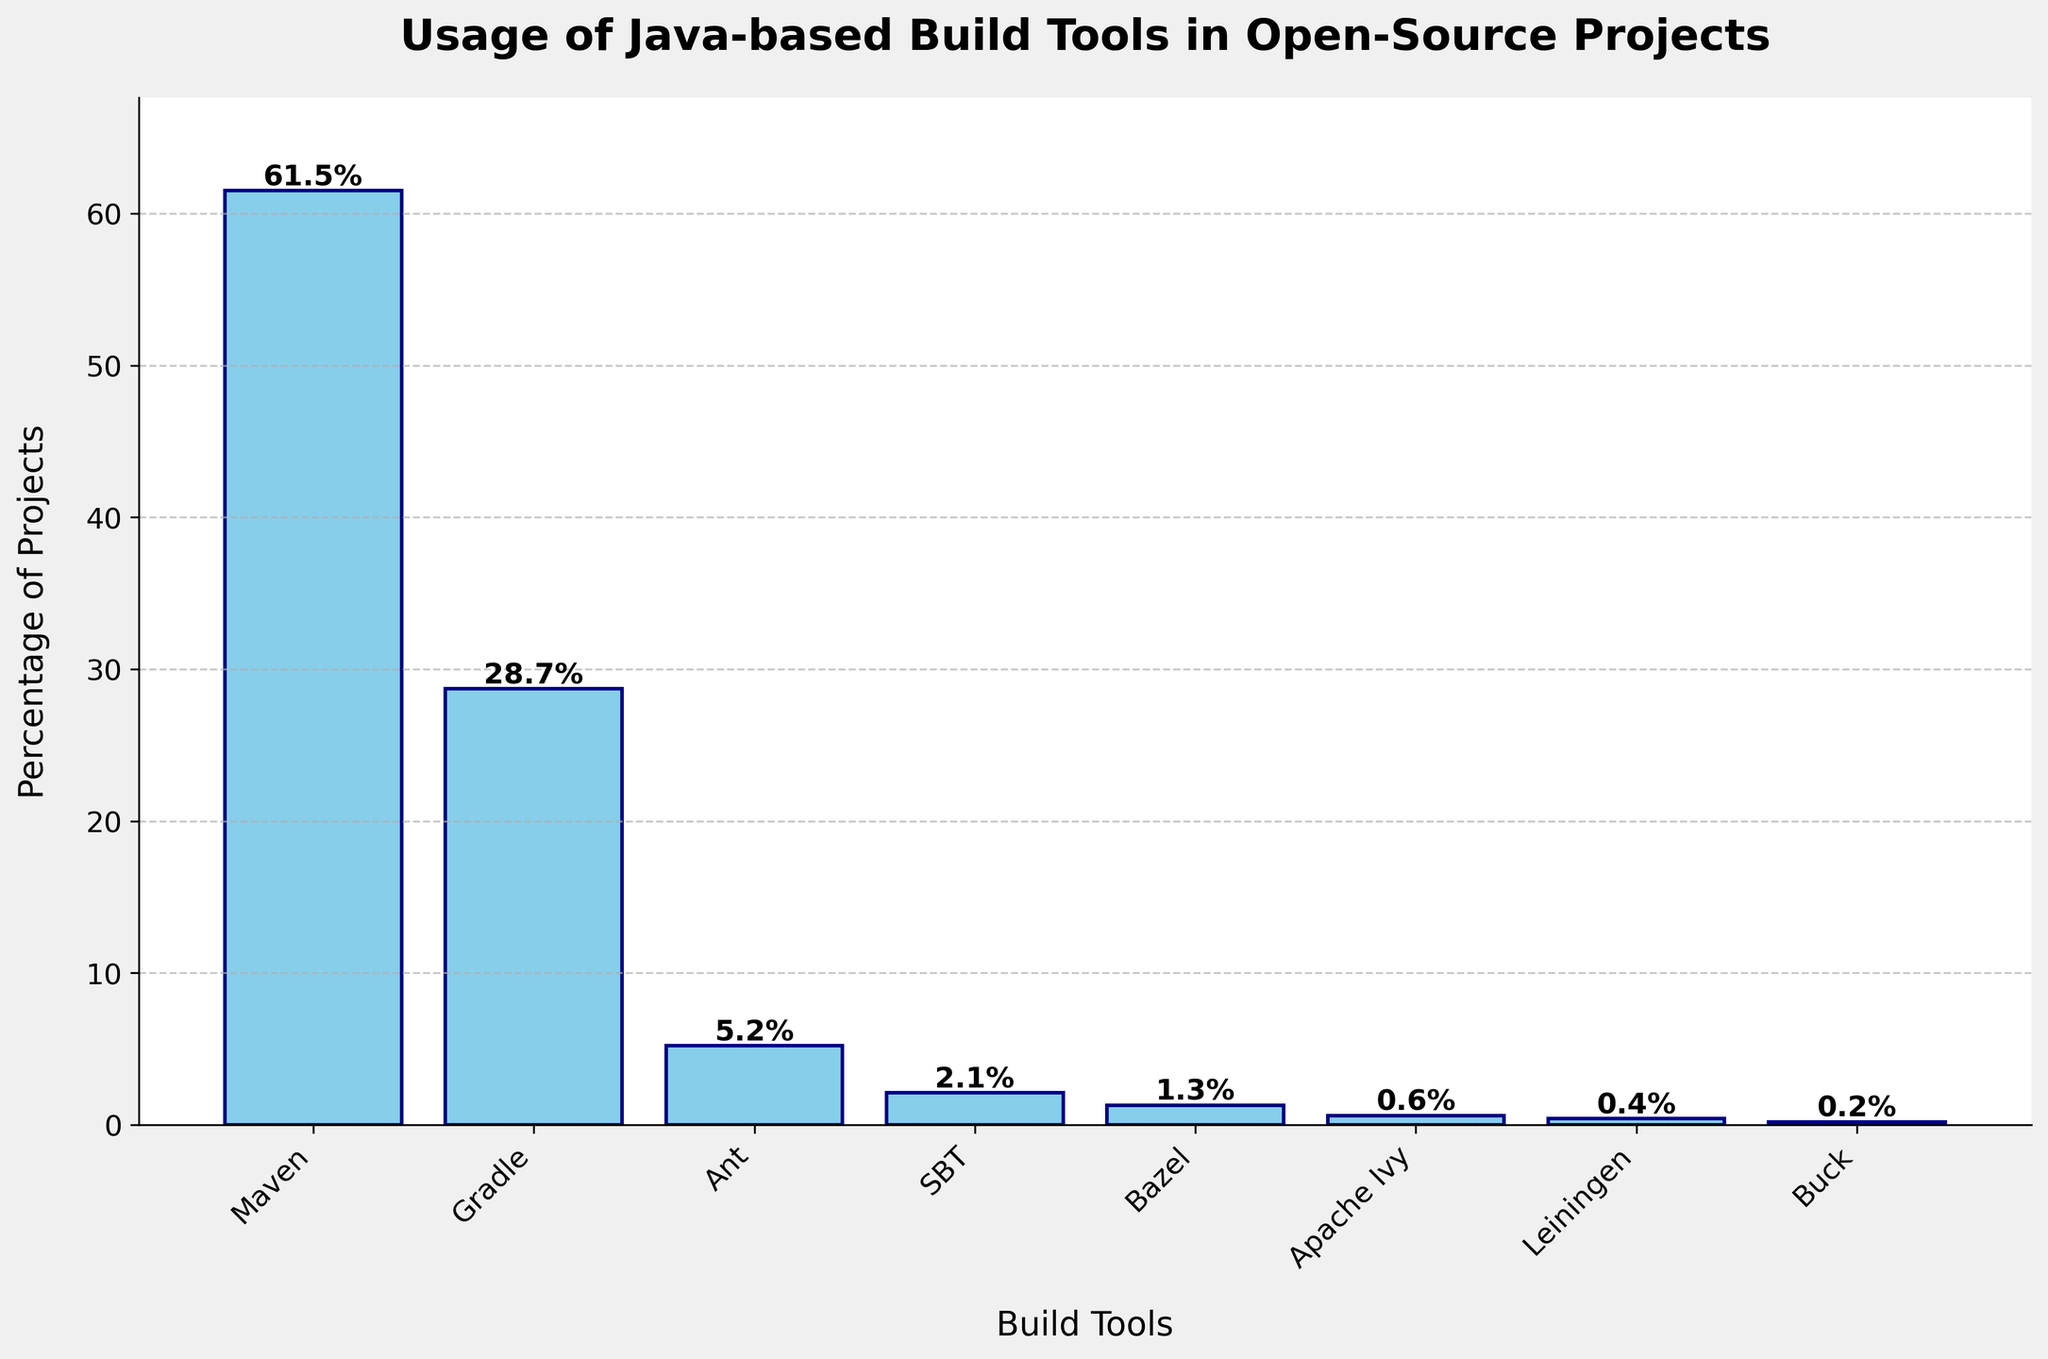what is the most commonly used Java-based build tool in open-source projects? From the bar chart, the tallest bar represents Maven with a height indicating it is used in 61.5% of projects.
Answer: Maven Which build tool has the smallest usage percentage? The shortest bar in the chart is for Buck, indicating it is used in 0.2% of the projects.
Answer: Buck How much more popular is Maven compared to Gradle? Maven is used in 61.5% of projects while Gradle is used in 28.7%. The difference in their usage percentages is 61.5 - 28.7, which is 32.8.
Answer: 32.8% Which build tools have a combined usage percentage less than 5%? The sum of the usage percentages is: Ant (5.2%) + SBT (2.1%) + Bazel (1.3%) + Apache Ivy (0.6%) + Leiningen (0.4%) + Buck (0.2%) = 9.8%. Therefore, excluding Ant, the rest have less than 5% usage.
Answer: SBT, Bazel, Apache Ivy, Leiningen, Buck If you combine the usage percentages of the three most popular build tools, what total do you get? The three most popular tools are Maven (61.5%), Gradle (28.7%), and Ant (5.2%). Summing them up: 61.5 + 28.7 + 5.2 = 95.4.
Answer: 95.4% Which build tools have usage percentages between 1% and 3%? From the chart, SBT (2.1%) and Bazel (1.3%) have usage percentages falling within this range.
Answer: SBT, Bazel What is the difference in usage percentage between Ant and SBT? Ant is used in 5.2% of projects, and SBT in 2.1%. The difference is 5.2 - 2.1, which is 3.1.
Answer: 3.1% Which build tools have usage percentages below 1%? The bars for Apache Ivy (0.6%), Leiningen (0.4%), and Buck (0.2%) are shorter than the 1% mark.
Answer: Apache Ivy, Leiningen, Buck What is the sum of the usage percentages for the least popular three build tools? The least popular three build tools are Apache Ivy (0.6%), Leiningen (0.4%), and Buck (0.2%). Summing them, we get 0.6 + 0.4 + 0.2 = 1.2.
Answer: 1.2% Which build tool has slightly more than half the usage percentage of Gradle? Gradle has a usage percentage of 28.7%. Ant, with 5.2%, is just over half of Gradle's percentage. To verify: 5.2 / 28.7 ≈ 0.18.
Answer: Ant 